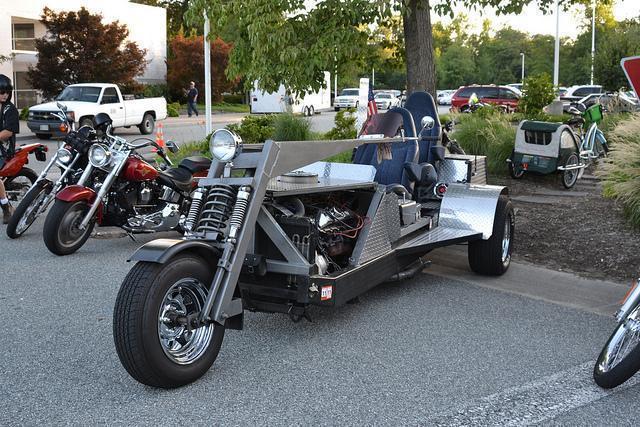How many cylinders does the engine in this custom tricycle have?
Pick the right solution, then justify: 'Answer: answer
Rationale: rationale.'
Options: Six, eight, four, 12. Answer: eight.
Rationale: The tricycle has 8 cylinders in total. 